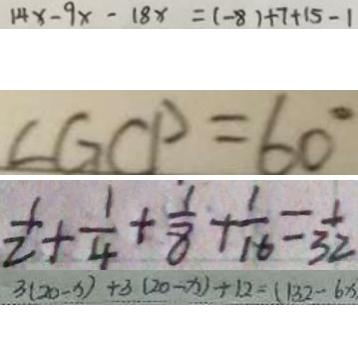Convert formula to latex. <formula><loc_0><loc_0><loc_500><loc_500>1 4 x - 9 x - 1 8 x = ( - 8 ) + 7 + 1 5 - 1 
 \angle G C P = 6 0 ^ { \circ } 
 \frac { 1 } { 2 } + \frac { 1 } { 4 } + \frac { 1 } { 8 } + \frac { 1 } { 1 6 } = \frac { 1 } { 3 2 } 
 3 ( 2 0 - x ) + 3 ( 2 0 - x ) \div 1 2 = ( 1 3 2 - 6 x )</formula> 